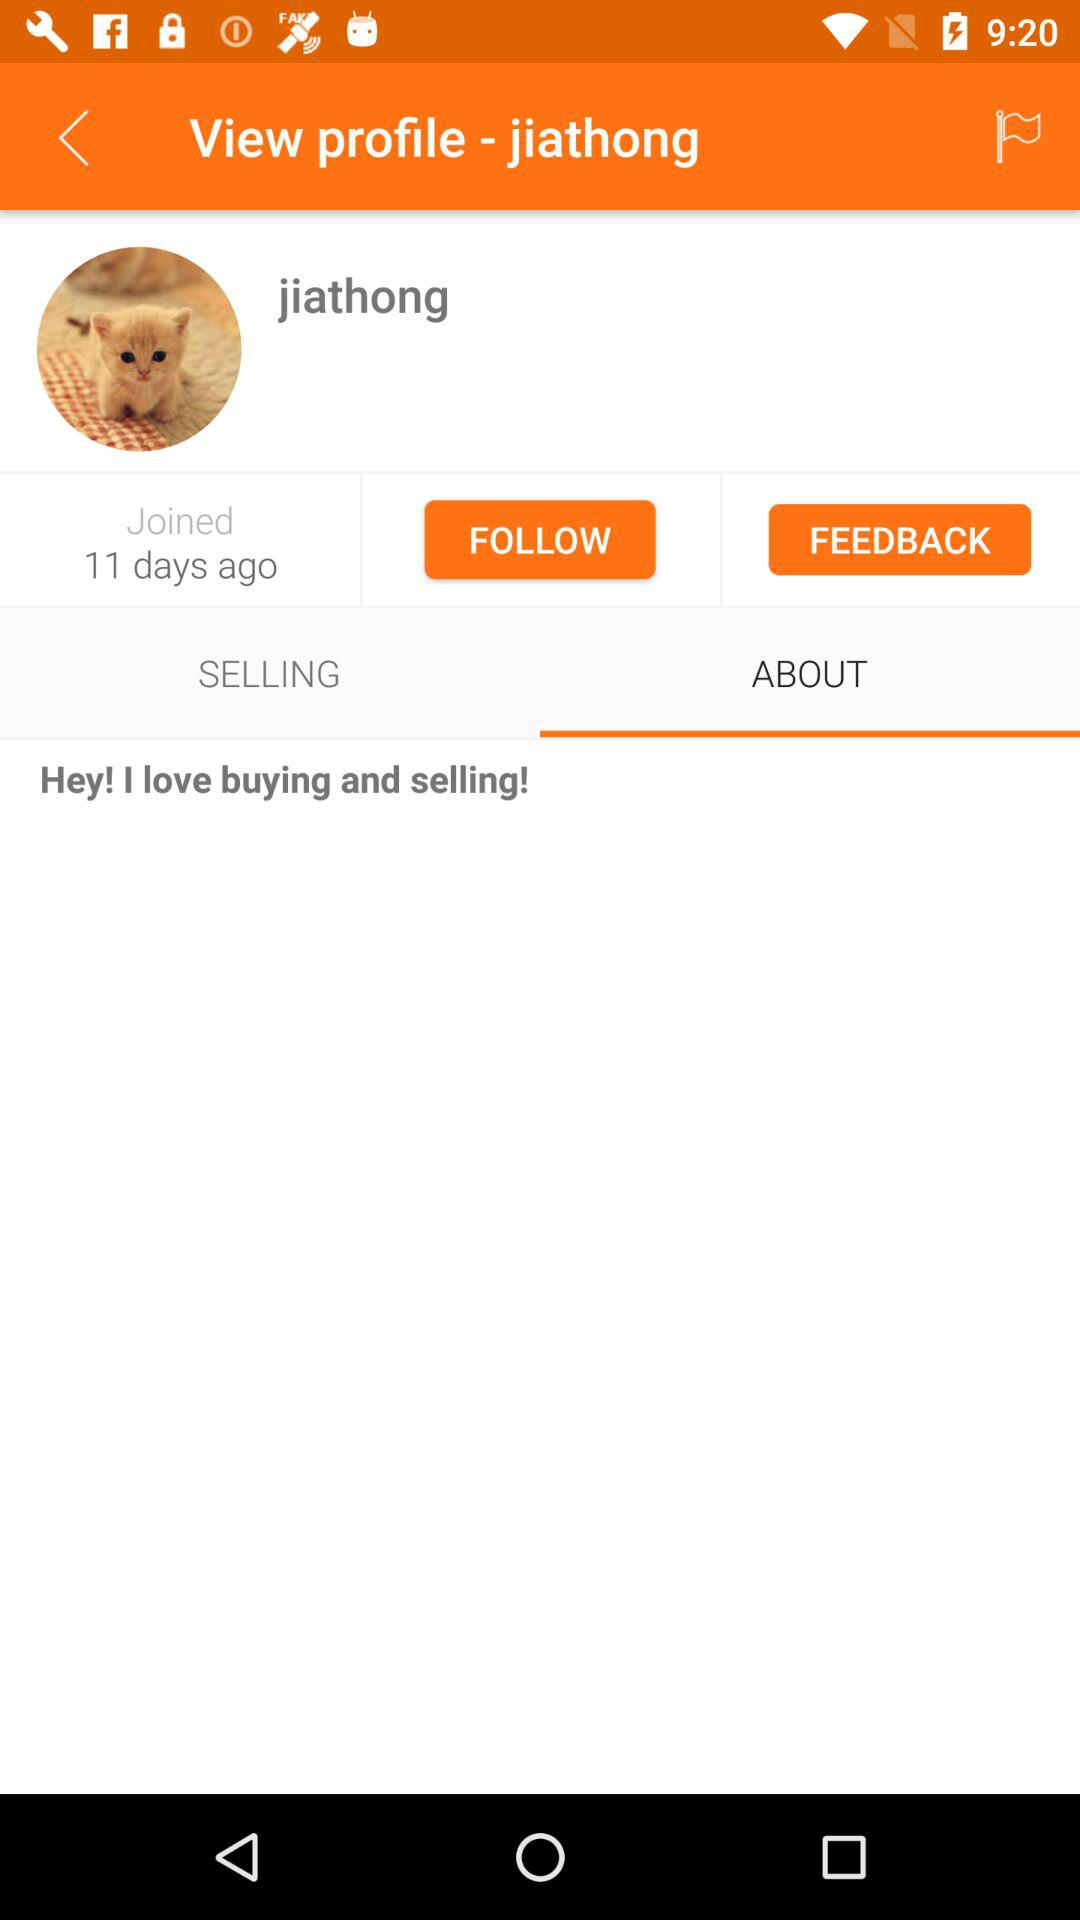What's the user profile name? The user profile name is Jiathong. 